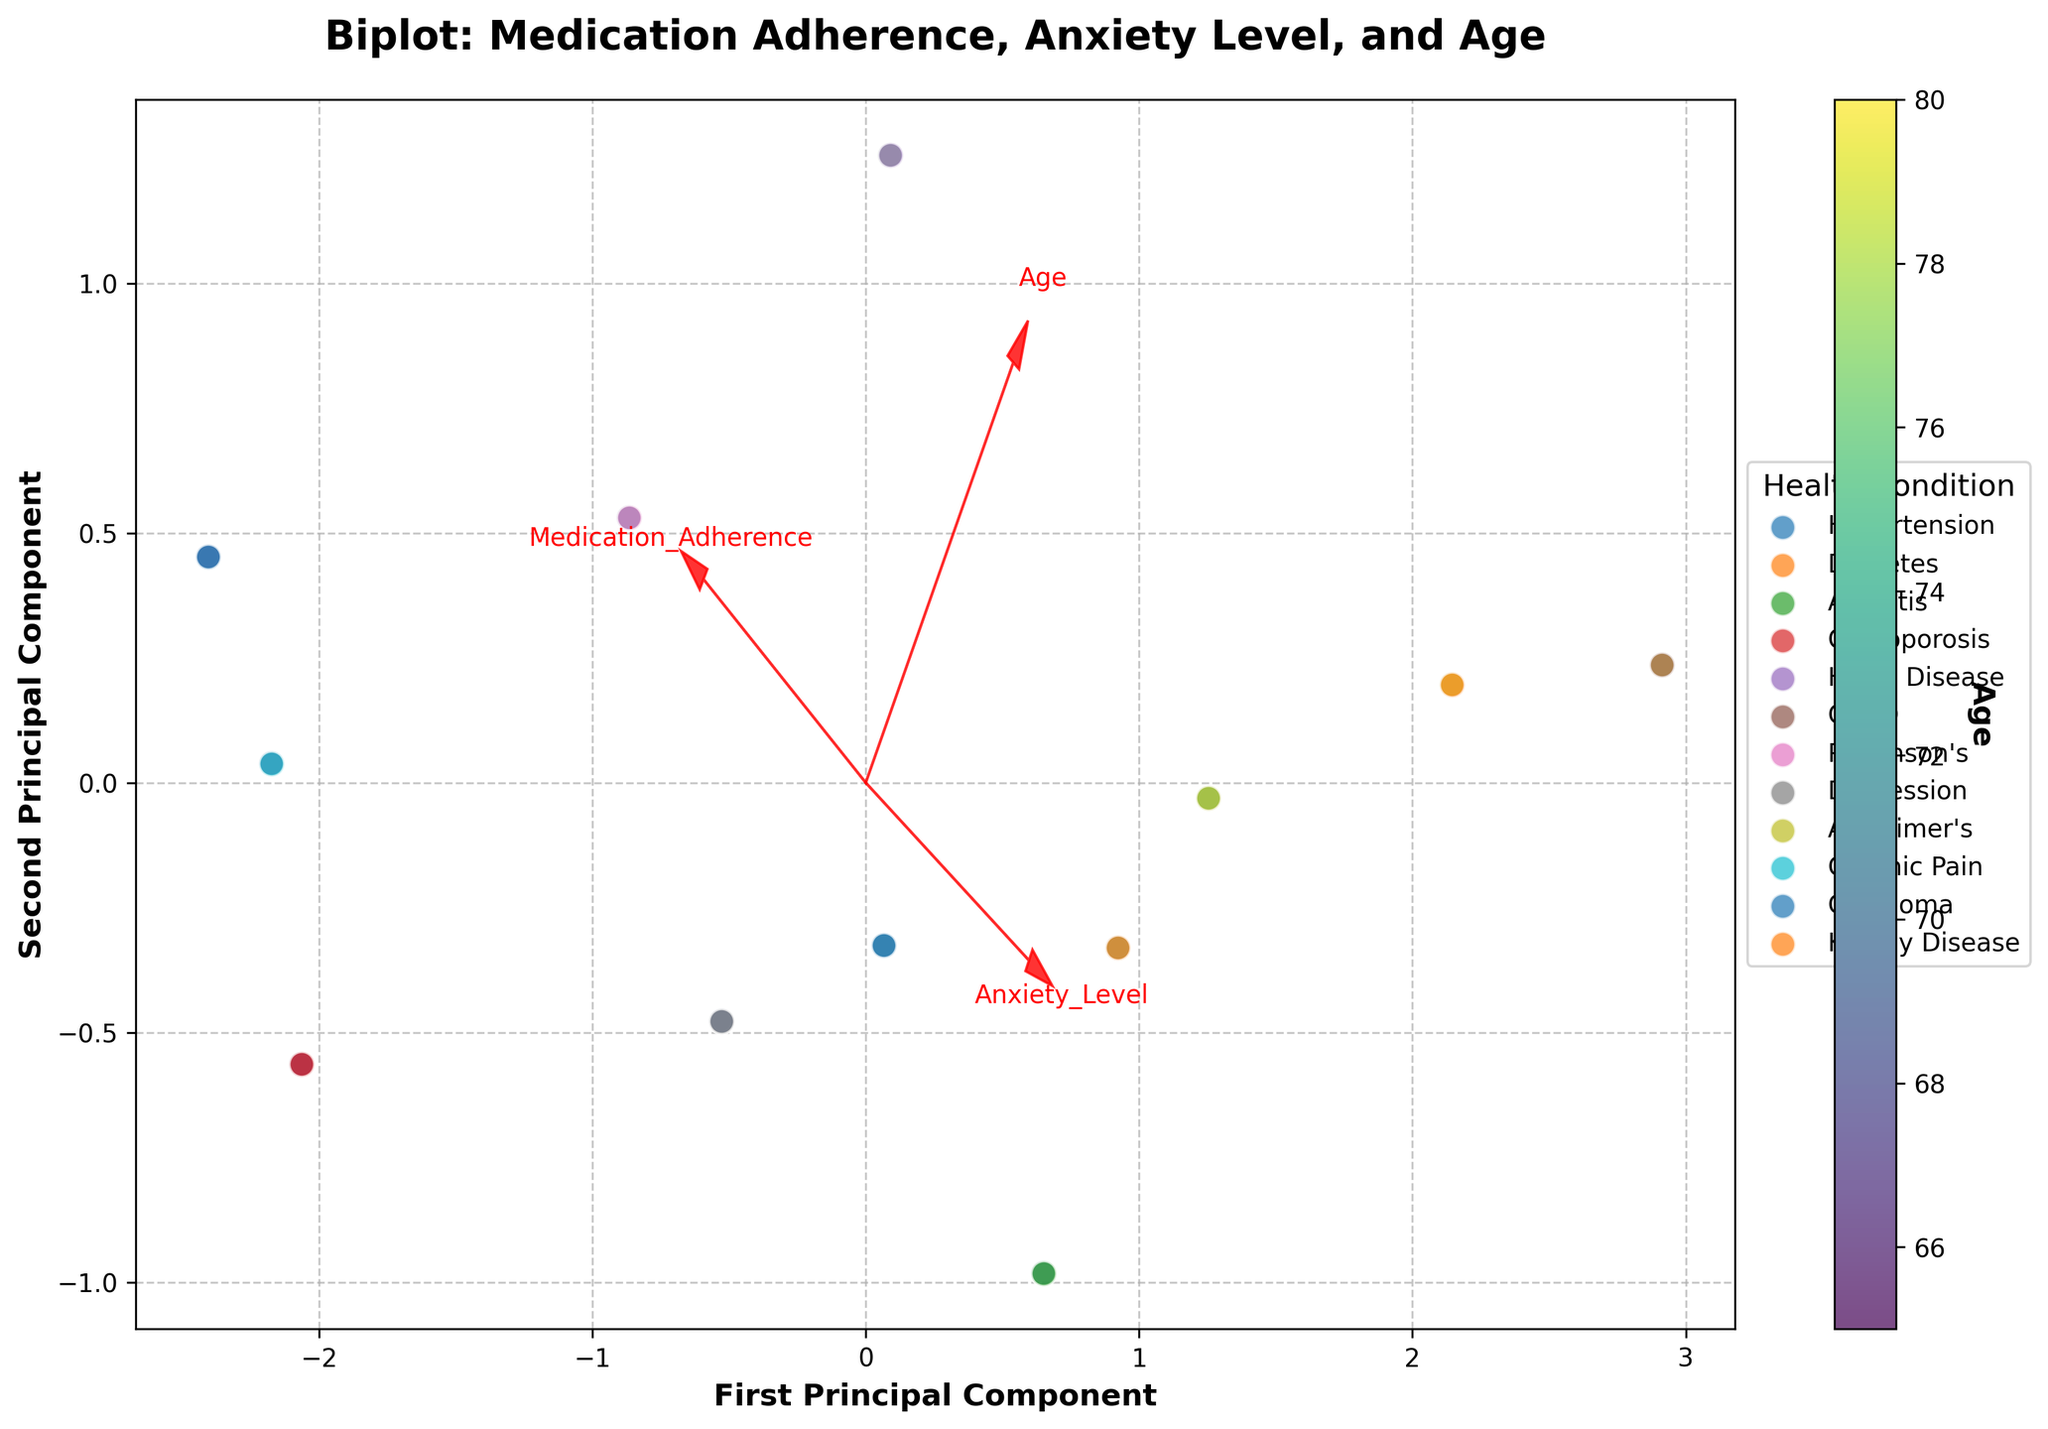How many principal components are shown in the biplot? The biplot has two axes labeled as the "First Principal Component" and "Second Principal Component," indicating that two principal components are shown.
Answer: Two What does the color of the data points represent? The color gradient visible in the scatter plot, represented by the color bar on the right side, signifies age. The label "Age" on the color bar confirms this.
Answer: Age Which health condition appears to have the weakest support network based on the scatter plot? By examining the scatter plot, we see that the health conditions like COPD, Kidney Disease, and Alzheimer's are marked with similar colors that correlate to weaker support networks, as reflected in the dataset provided.
Answer: COPD, Kidney Disease, Alzheimer's What is the relationship between medication adherence and anxiety levels based on the biplot vectors? The vectors in the biplot indicate the directions of maximum variance. If the medication adherence and anxiety levels arrows point in opposite directions, there is a negative correlation; if they point in the same direction, there is a positive correlation. Here, the specific directions can be deduced by their alignment.
Answer: Negative correlation How can you identify the principal component that accounts for the most variance? The axis (either First Principal Component or Second Principal Component) with a larger spread of data points indicates higher variance. The axis label or an accompanying eigenvalue can provide more precise identification.
Answer: First Principal Component Which age group seems to have higher medication adherence and lower anxiety levels? By observing the data point distribution and color gradient on the First Principle Component, younger seniors (lighter colors) are spread more across high adherence and low anxiety regions.
Answer: Younger seniors Does anyone with a strong support network and a chronic health condition experience high anxiety levels? Inspect the scatter plot data points that represent a strong support network, e.g., Hypertension, Osteoporosis, and Parkinson's. Their positioning in regions of lower anxiety levels suggests no high anxiety cases.
Answer: No Do older seniors tend to have higher medication adherence according to the biplot? The color gradient representing age in the scatter plot shows whether older seniors are spread mostly in the regions corresponding to higher medication adherence values.
Answer: No In general, do anxiety levels correlate more strongly with medication adherence or age in seniors? The relative directions of the vector arrows for Anxiety_Level, Medication_Adherence, and Age can indicate the strength of their inter-correlation.
Answer: Medication adherence 